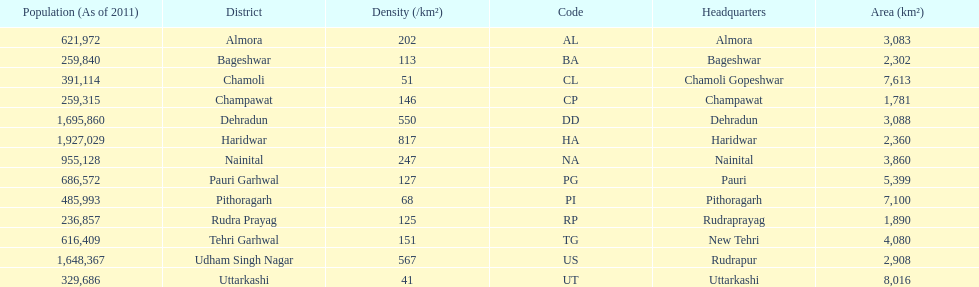Which has a larger population, dehradun or nainital? Dehradun. 